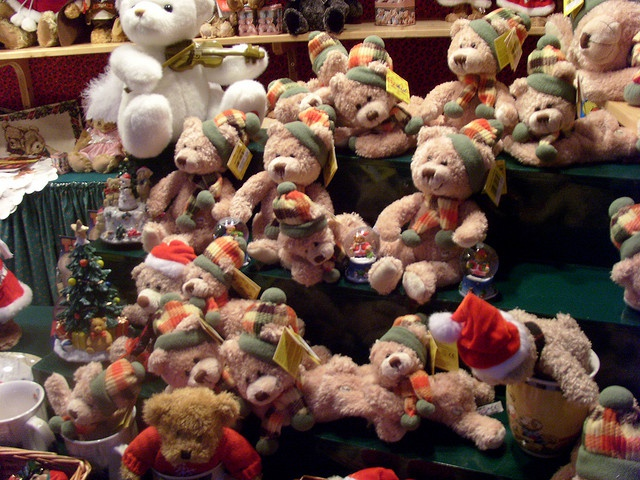Describe the objects in this image and their specific colors. I can see teddy bear in olive, maroon, black, and gray tones, teddy bear in olive, ivory, darkgray, tan, and gray tones, teddy bear in olive, maroon, gray, black, and tan tones, teddy bear in olive, maroon, brown, black, and tan tones, and teddy bear in olive, tan, maroon, gray, and black tones in this image. 